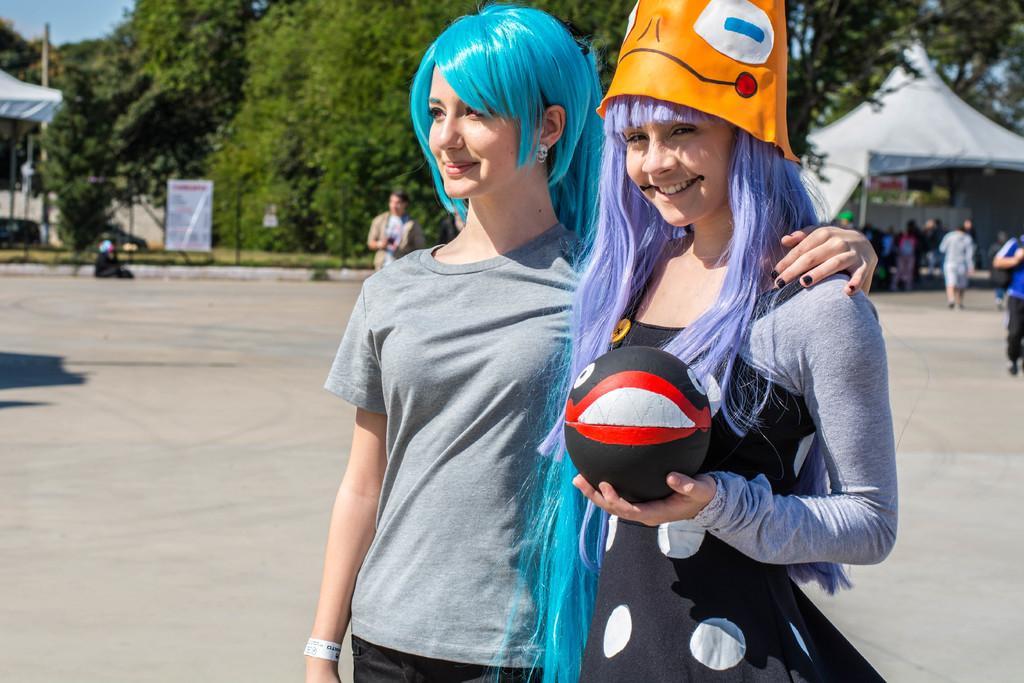Could you give a brief overview of what you see in this image? In this given picture there are two girls those who are standing at the right side of the image, and the girl is holding a ball in her hand and there are some trees around the area of the image and it is a day time, the color of hair is different of these two girls. 